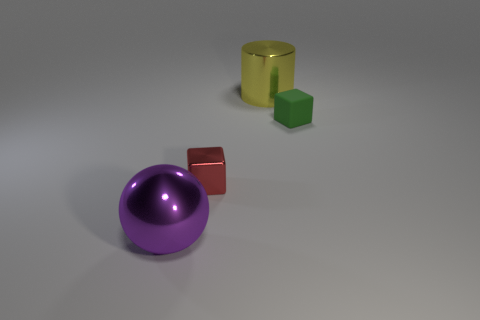Is there a big sphere behind the small block that is right of the large metallic cylinder?
Offer a very short reply. No. Does the small block in front of the small green block have the same material as the large ball?
Give a very brief answer. Yes. How many tiny things are behind the tiny red metal object and left of the small green block?
Provide a short and direct response. 0. What number of other small blocks have the same material as the green cube?
Your answer should be very brief. 0. There is a ball that is made of the same material as the yellow cylinder; what is its color?
Keep it short and to the point. Purple. Is the number of blue balls less than the number of red shiny things?
Offer a very short reply. Yes. What is the large object that is behind the large shiny thing that is in front of the cube to the left of the small green rubber thing made of?
Make the answer very short. Metal. What is the material of the green object?
Your answer should be very brief. Rubber. Does the tiny thing that is behind the red block have the same color as the large thing that is behind the purple shiny object?
Give a very brief answer. No. Is the number of gray matte cylinders greater than the number of tiny green matte cubes?
Provide a short and direct response. No. 